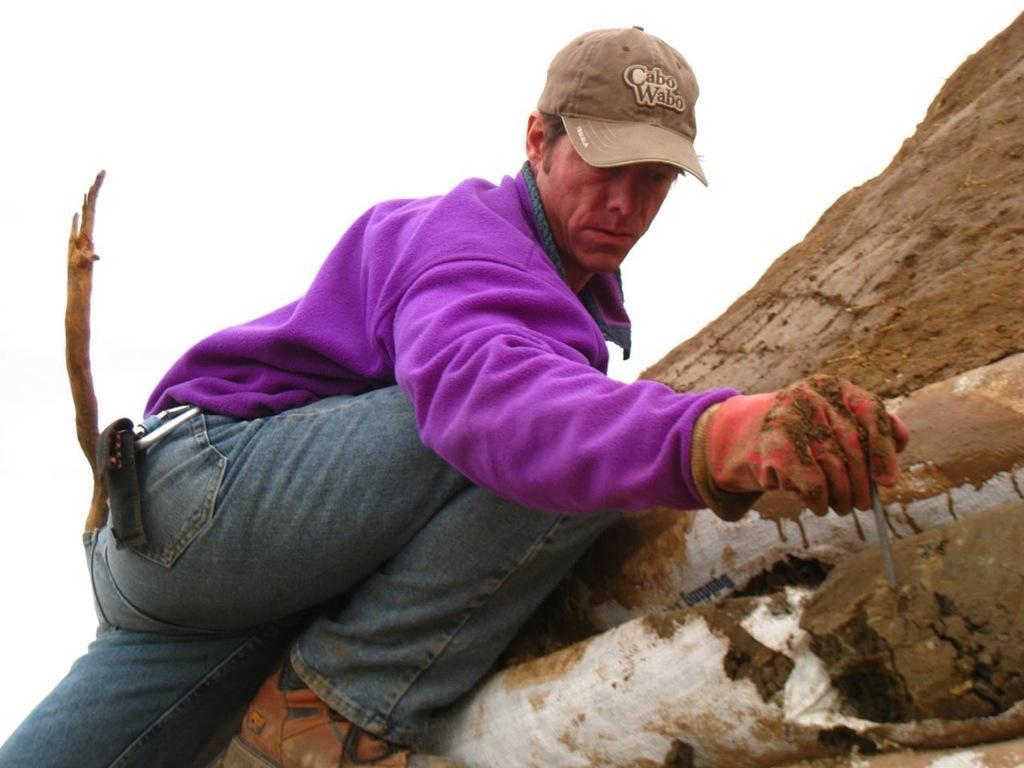Can you describe this image briefly? In this image I can see a person climbing a mountain. The person is wearing purple shirt, blue color jeans, background I can see sky in white color. 